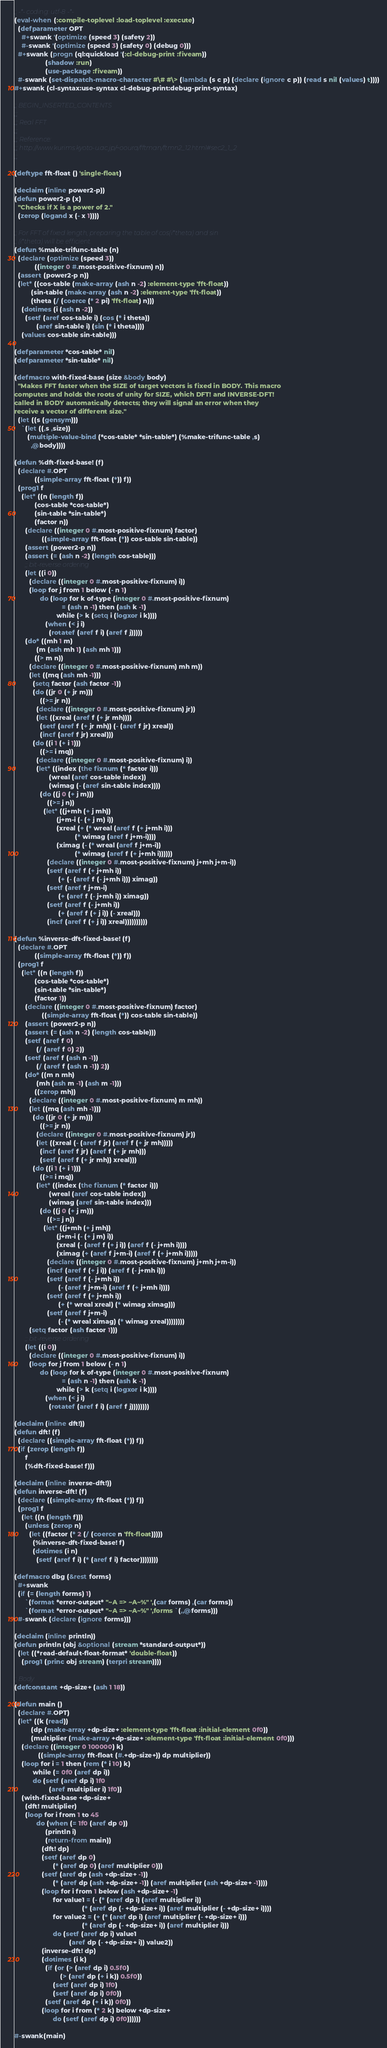<code> <loc_0><loc_0><loc_500><loc_500><_Lisp_>;; -*- coding: utf-8 -*-
(eval-when (:compile-toplevel :load-toplevel :execute)
  (defparameter OPT
    #+swank '(optimize (speed 3) (safety 2))
    #-swank '(optimize (speed 3) (safety 0) (debug 0)))
  #+swank (progn (ql:quickload '(:cl-debug-print :fiveam))
                 (shadow :run)
                 (use-package :fiveam))
  #-swank (set-dispatch-macro-character #\# #\> (lambda (s c p) (declare (ignore c p)) (read s nil (values) t))))
#+swank (cl-syntax:use-syntax cl-debug-print:debug-print-syntax)

;; BEGIN_INSERTED_CONTENTS
;;;
;;; Real FFT
;;;
;;; Reference:
;;; http://www.kurims.kyoto-u.ac.jp/~ooura/fftman/ftmn2_12.html#sec2_1_2
;;;

(deftype fft-float () 'single-float)

(declaim (inline power2-p))
(defun power2-p (x)
  "Checks if X is a power of 2."
  (zerop (logand x (- x 1))))

;; For FFT of fixed length, preparing the table of cos(i*theta) and sin
;; (i*theta) will be efficient.
(defun %make-trifunc-table (n)
  (declare (optimize (speed 3))
           ((integer 0 #.most-positive-fixnum) n))
  (assert (power2-p n))
  (let* ((cos-table (make-array (ash n -2) :element-type 'fft-float))
         (sin-table (make-array (ash n -2) :element-type 'fft-float))
         (theta (/ (coerce (* 2 pi) 'fft-float) n)))
    (dotimes (i (ash n -2))
      (setf (aref cos-table i) (cos (* i theta))
            (aref sin-table i) (sin (* i theta))))
    (values cos-table sin-table)))

(defparameter *cos-table* nil)
(defparameter *sin-table* nil)

(defmacro with-fixed-base (size &body body)
  "Makes FFT faster when the SIZE of target vectors is fixed in BODY. This macro
computes and holds the roots of unity for SIZE, which DFT! and INVERSE-DFT!
called in BODY automatically detects; they will signal an error when they
receive a vector of different size."
  (let ((s (gensym)))
    `(let ((,s ,size))
       (multiple-value-bind (*cos-table* *sin-table*) (%make-trifunc-table ,s)
         ,@body))))

(defun %dft-fixed-base! (f)
  (declare #.OPT
           ((simple-array fft-float (*)) f))
  (prog1 f
    (let* ((n (length f))
           (cos-table *cos-table*)
           (sin-table *sin-table*)
           (factor n))
      (declare ((integer 0 #.most-positive-fixnum) factor)
               ((simple-array fft-float (*)) cos-table sin-table))
      (assert (power2-p n))
      (assert (= (ash n -2) (length cos-table)))
      ;; bit-reverse ordering
      (let ((i 0))
        (declare ((integer 0 #.most-positive-fixnum) i))
        (loop for j from 1 below (- n 1)
              do (loop for k of-type (integer 0 #.most-positive-fixnum)
                          = (ash n -1) then (ash k -1)
                       while (> k (setq i (logxor i k))))
                 (when (< j i)
                   (rotatef (aref f i) (aref f j)))))
      (do* ((mh 1 m)
            (m (ash mh 1) (ash mh 1)))
           ((> m n))
        (declare ((integer 0 #.most-positive-fixnum) mh m))
        (let ((mq (ash mh -1)))
          (setq factor (ash factor -1))
          (do ((jr 0 (+ jr m)))
              ((>= jr n))
            (declare ((integer 0 #.most-positive-fixnum) jr))
            (let ((xreal (aref f (+ jr mh))))
              (setf (aref f (+ jr mh)) (- (aref f jr) xreal))
              (incf (aref f jr) xreal)))
          (do ((i 1 (+ i 1)))
              ((>= i mq))
            (declare ((integer 0 #.most-positive-fixnum) i))
            (let* ((index (the fixnum (* factor i)))
                   (wreal (aref cos-table index))
                   (wimag (- (aref sin-table index))))
              (do ((j 0 (+ j m)))
                  ((>= j n))
                (let* ((j+mh (+ j mh))
                       (j+m-i (- (+ j m) i))
                       (xreal (+ (* wreal (aref f (+ j+mh i)))
                                 (* wimag (aref f j+m-i))))
                       (ximag (- (* wreal (aref f j+m-i))
                                 (* wimag (aref f (+ j+mh i))))))
                  (declare ((integer 0 #.most-positive-fixnum) j+mh j+m-i))
                  (setf (aref f (+ j+mh i))
                        (+ (- (aref f (- j+mh i))) ximag))
                  (setf (aref f j+m-i)
                        (+ (aref f (- j+mh i)) ximag))
                  (setf (aref f (- j+mh i))
                        (+ (aref f (+ j i)) (- xreal)))
                  (incf (aref f (+ j i)) xreal))))))))))

(defun %inverse-dft-fixed-base! (f)
  (declare #.OPT
           ((simple-array fft-float (*)) f))
  (prog1 f
    (let* ((n (length f))
           (cos-table *cos-table*)
           (sin-table *sin-table*)
           (factor 1))
      (declare ((integer 0 #.most-positive-fixnum) factor)
               ((simple-array fft-float (*)) cos-table sin-table))
      (assert (power2-p n))
      (assert (= (ash n -2) (length cos-table)))
      (setf (aref f 0)
            (/ (aref f 0) 2))
      (setf (aref f (ash n -1))
            (/ (aref f (ash n -1)) 2))
      (do* ((m n mh)
            (mh (ash m -1) (ash m -1)))
           ((zerop mh))
        (declare ((integer 0 #.most-positive-fixnum) m mh))
        (let ((mq (ash mh -1)))
          (do ((jr 0 (+ jr m)))
              ((>= jr n))
            (declare ((integer 0 #.most-positive-fixnum) jr))
            (let ((xreal (- (aref f jr) (aref f (+ jr mh)))))
              (incf (aref f jr) (aref f (+ jr mh)))
              (setf (aref f (+ jr mh)) xreal)))
          (do ((i 1 (+ i 1)))
              ((>= i mq))
            (let* ((index (the fixnum (* factor i)))
                   (wreal (aref cos-table index))
                   (wimag (aref sin-table index)))
              (do ((j 0 (+ j m)))
                  ((>= j n))
                (let* ((j+mh (+ j mh))
                       (j+m-i (- (+ j m) i))
                       (xreal (- (aref f (+ j i)) (aref f (- j+mh i))))
                       (ximag (+ (aref f j+m-i) (aref f (+ j+mh i)))))
                  (declare ((integer 0 #.most-positive-fixnum) j+mh j+m-i))
                  (incf (aref f (+ j i)) (aref f (- j+mh i)))
                  (setf (aref f (- j+mh i))
                        (- (aref f j+m-i) (aref f (+ j+mh i))))
                  (setf (aref f (+ j+mh i))
                        (+ (* wreal xreal) (* wimag ximag)))
                  (setf (aref f j+m-i)
                        (- (* wreal ximag) (* wimag xreal))))))))
        (setq factor (ash factor 1)))
      ;; bit-reverse ordering
      (let ((i 0))
        (declare ((integer 0 #.most-positive-fixnum) i))
        (loop for j from 1 below (- n 1)
              do (loop for k of-type (integer 0 #.most-positive-fixnum)
                          = (ash n -1) then (ash k -1)
                       while (> k (setq i (logxor i k))))
                 (when (< j i)
                   (rotatef (aref f i) (aref f j))))))))

(declaim (inline dft!))
(defun dft! (f)
  (declare ((simple-array fft-float (*)) f))
  (if (zerop (length f))
      f
      (%dft-fixed-base! f)))

(declaim (inline inverse-dft!))
(defun inverse-dft! (f)
  (declare ((simple-array fft-float (*)) f))
  (prog1 f
    (let ((n (length f)))
      (unless (zerop n)
        (let ((factor (* 2 (/ (coerce n 'fft-float)))))
          (%inverse-dft-fixed-base! f)
          (dotimes (i n)
            (setf (aref f i) (* (aref f i) factor))))))))

(defmacro dbg (&rest forms)
  #+swank
  (if (= (length forms) 1)
      `(format *error-output* "~A => ~A~%" ',(car forms) ,(car forms))
      `(format *error-output* "~A => ~A~%" ',forms `(,,@forms)))
  #-swank (declare (ignore forms)))

(declaim (inline println))
(defun println (obj &optional (stream *standard-output*))
  (let ((*read-default-float-format* 'double-float))
    (prog1 (princ obj stream) (terpri stream))))

;; Body
(defconstant +dp-size+ (ash 1 18))

(defun main ()
  (declare #.OPT)
  (let* ((k (read))
         (dp (make-array +dp-size+ :element-type 'fft-float :initial-element 0f0))
         (multiplier (make-array +dp-size+ :element-type 'fft-float :initial-element 0f0)))
    (declare ((integer 0 100000) k)
             ((simple-array fft-float (#.+dp-size+)) dp multiplier))
    (loop for i = 1 then (rem (* i 10) k)
          while (= 0f0 (aref dp i))
          do (setf (aref dp i) 1f0
                   (aref multiplier i) 1f0))
    (with-fixed-base +dp-size+
      (dft! multiplier)
      (loop for i from 1 to 45
            do (when (= 1f0 (aref dp 0))
                 (println i)
                 (return-from main))
               (dft! dp)
               (setf (aref dp 0)
                     (* (aref dp 0) (aref multiplier 0)))
               (setf (aref dp (ash +dp-size+ -1))
                     (* (aref dp (ash +dp-size+ -1)) (aref multiplier (ash +dp-size+ -1))))
               (loop for i from 1 below (ash +dp-size+ -1)
                     for value1 = (- (* (aref dp i) (aref multiplier i))
                                     (* (aref dp (- +dp-size+ i)) (aref multiplier (- +dp-size+ i))))
                     for value2 = (+ (* (aref dp i) (aref multiplier (- +dp-size+ i)))
                                     (* (aref dp (- +dp-size+ i)) (aref multiplier i)))
                     do (setf (aref dp i) value1
                              (aref dp (- +dp-size+ i)) value2))
               (inverse-dft! dp)
               (dotimes (i k)
                 (if (or (> (aref dp i) 0.5f0)
                         (> (aref dp (+ i k)) 0.5f0))
                     (setf (aref dp i) 1f0)
                     (setf (aref dp i) 0f0))
                 (setf (aref dp (+ i k)) 0f0))
               (loop for i from (* 2 k) below +dp-size+
                     do (setf (aref dp i) 0f0))))))

#-swank(main)
</code> 